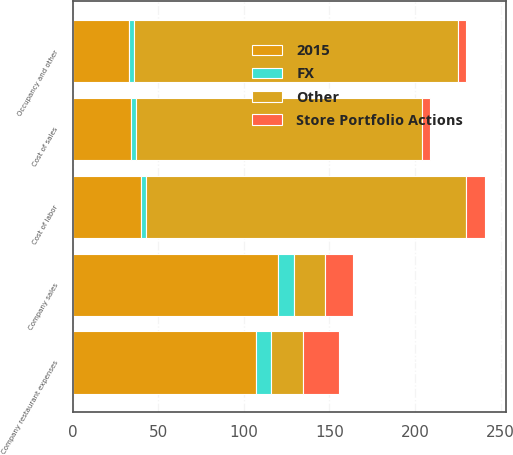Convert chart to OTSL. <chart><loc_0><loc_0><loc_500><loc_500><stacked_bar_chart><ecel><fcel>Company sales<fcel>Cost of sales<fcel>Cost of labor<fcel>Occupancy and other<fcel>Company restaurant expenses<nl><fcel>Other<fcel>18.5<fcel>167<fcel>187<fcel>189<fcel>18.5<nl><fcel>2015<fcel>120<fcel>34<fcel>40<fcel>33<fcel>107<nl><fcel>Store Portfolio Actions<fcel>16<fcel>5<fcel>11<fcel>5<fcel>21<nl><fcel>FX<fcel>9<fcel>3<fcel>3<fcel>3<fcel>9<nl></chart> 